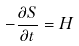<formula> <loc_0><loc_0><loc_500><loc_500>- \frac { \partial S } { \partial t } = H</formula> 